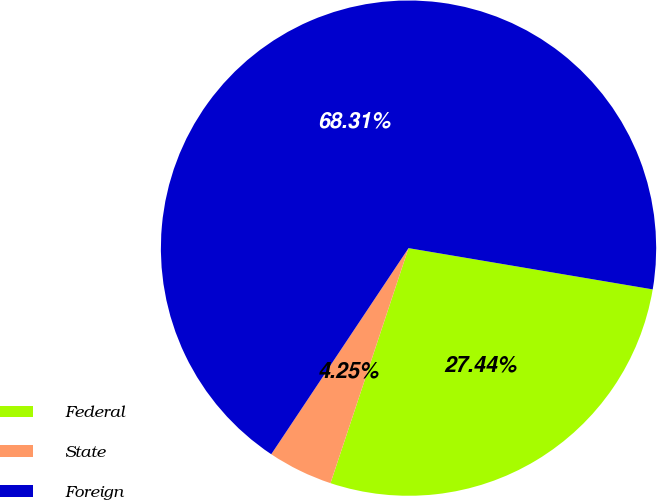Convert chart. <chart><loc_0><loc_0><loc_500><loc_500><pie_chart><fcel>Federal<fcel>State<fcel>Foreign<nl><fcel>27.44%<fcel>4.25%<fcel>68.32%<nl></chart> 